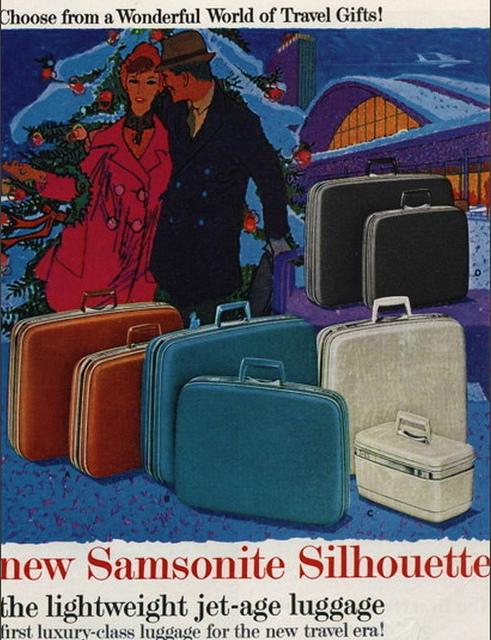How many sets of suitcases are there?
Concise answer only. 4. Is there a white set of luggage?
Be succinct. Yes. What is this ad for?
Give a very brief answer. Luggage. What is being advertised?
Answer briefly. Luggage. Does the blue suitcase look new?
Short answer required. Yes. How many bags are shown?
Concise answer only. 8. 